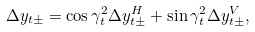Convert formula to latex. <formula><loc_0><loc_0><loc_500><loc_500>\Delta y _ { t \pm } = \cos \gamma _ { t } ^ { 2 } \Delta y _ { t \pm } ^ { H } + \sin \gamma _ { t } ^ { 2 } \Delta y _ { t \pm } ^ { V } ,</formula> 